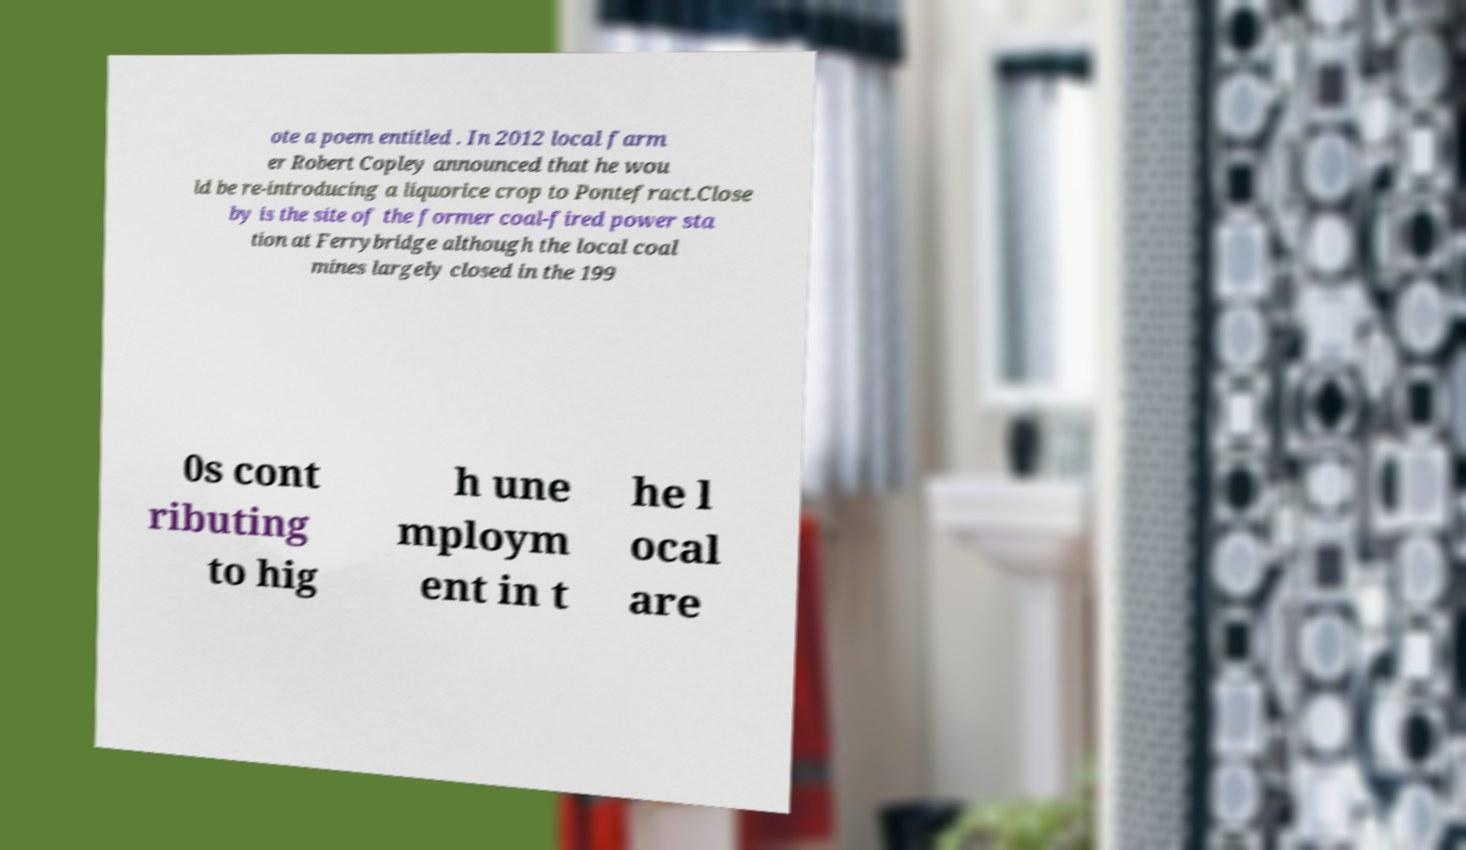Please read and relay the text visible in this image. What does it say? ote a poem entitled . In 2012 local farm er Robert Copley announced that he wou ld be re-introducing a liquorice crop to Pontefract.Close by is the site of the former coal-fired power sta tion at Ferrybridge although the local coal mines largely closed in the 199 0s cont ributing to hig h une mploym ent in t he l ocal are 